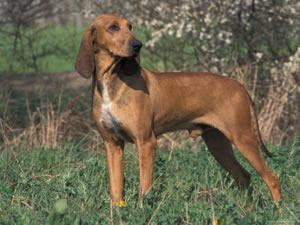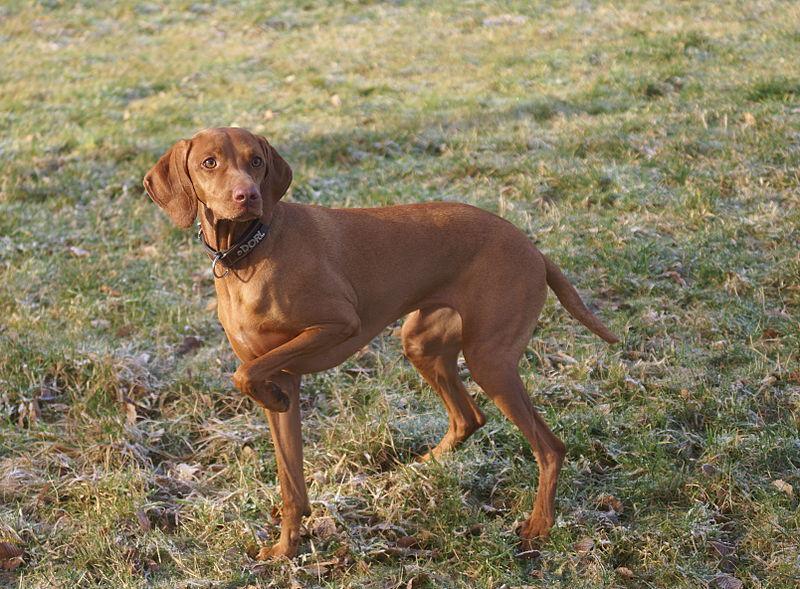The first image is the image on the left, the second image is the image on the right. Given the left and right images, does the statement "One of the images shows a brown dog with one of its front legs raised and the other image shows a brown dog standing in grass." hold true? Answer yes or no. Yes. The first image is the image on the left, the second image is the image on the right. For the images displayed, is the sentence "One dog has it's front leg up and bent in a pose." factually correct? Answer yes or no. Yes. 